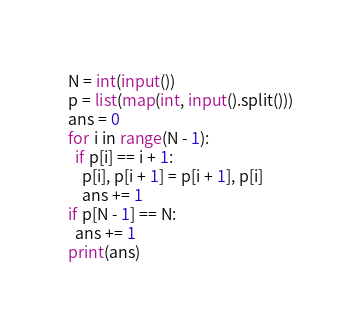Convert code to text. <code><loc_0><loc_0><loc_500><loc_500><_Python_>N = int(input())
p = list(map(int, input().split()))
ans = 0
for i in range(N - 1):
  if p[i] == i + 1:
    p[i], p[i + 1] = p[i + 1], p[i]
    ans += 1
if p[N - 1] == N:
  ans += 1
print(ans)</code> 